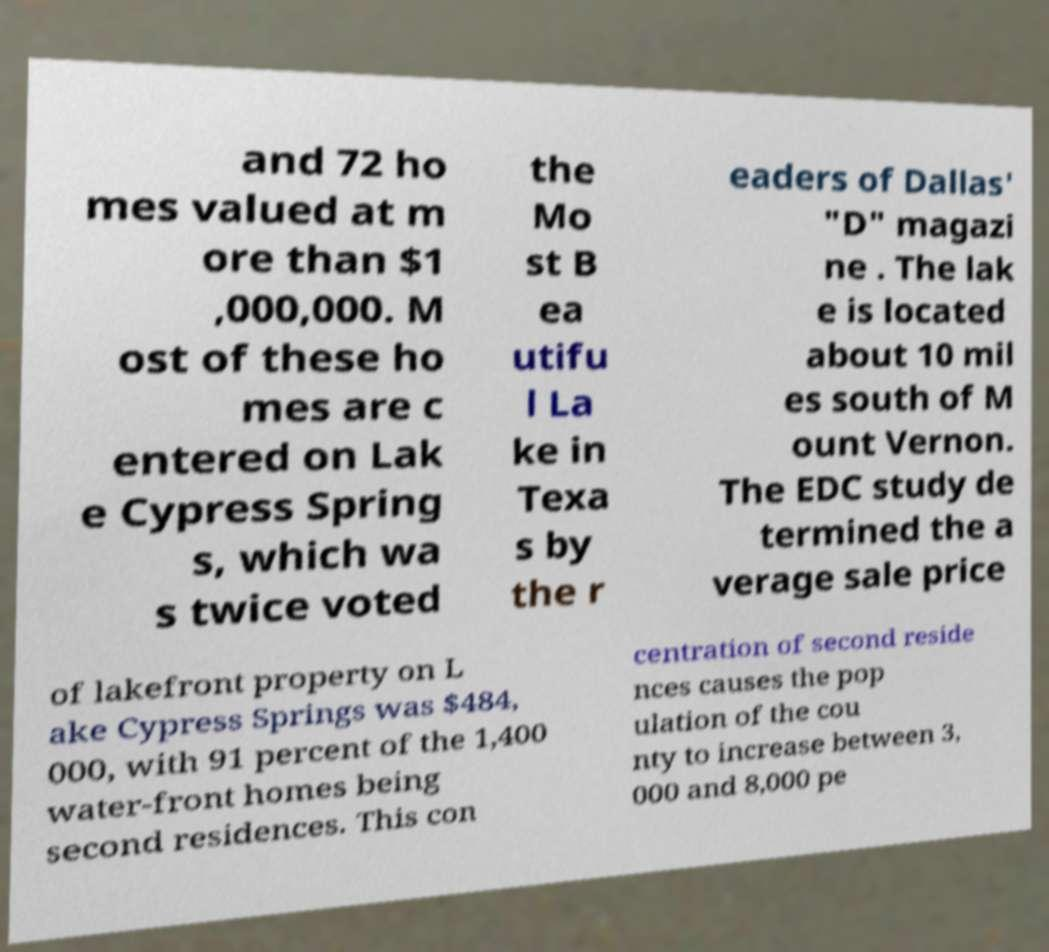Can you accurately transcribe the text from the provided image for me? and 72 ho mes valued at m ore than $1 ,000,000. M ost of these ho mes are c entered on Lak e Cypress Spring s, which wa s twice voted the Mo st B ea utifu l La ke in Texa s by the r eaders of Dallas' "D" magazi ne . The lak e is located about 10 mil es south of M ount Vernon. The EDC study de termined the a verage sale price of lakefront property on L ake Cypress Springs was $484, 000, with 91 percent of the 1,400 water-front homes being second residences. This con centration of second reside nces causes the pop ulation of the cou nty to increase between 3, 000 and 8,000 pe 